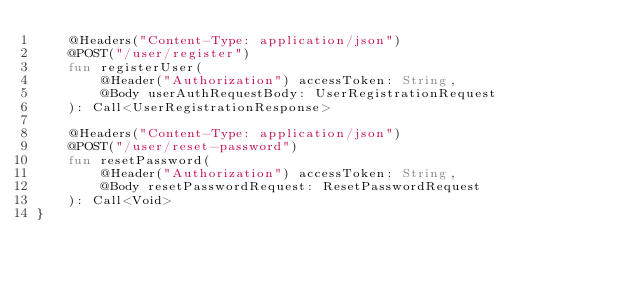<code> <loc_0><loc_0><loc_500><loc_500><_Kotlin_>	@Headers("Content-Type: application/json")
	@POST("/user/register")
	fun registerUser(
		@Header("Authorization") accessToken: String,
		@Body userAuthRequestBody: UserRegistrationRequest
	): Call<UserRegistrationResponse>

	@Headers("Content-Type: application/json")
	@POST("/user/reset-password")
	fun resetPassword(
		@Header("Authorization") accessToken: String,
		@Body resetPasswordRequest: ResetPasswordRequest
	): Call<Void>
}
</code> 